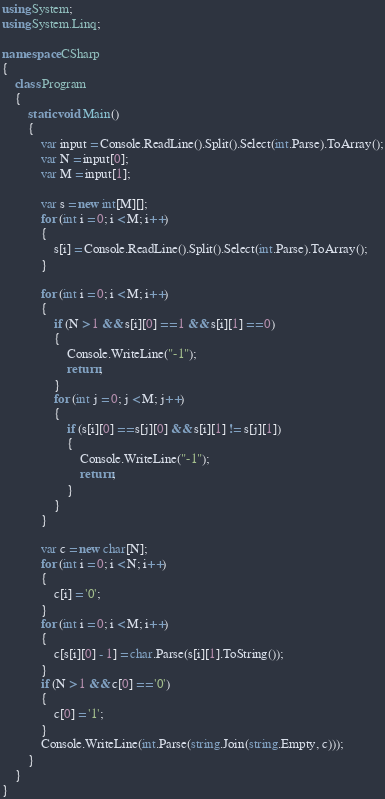<code> <loc_0><loc_0><loc_500><loc_500><_C#_>using System;
using System.Linq;

namespace CSharp
{
    class Program
    {
        static void Main()
        {
            var input = Console.ReadLine().Split().Select(int.Parse).ToArray();
            var N = input[0];
            var M = input[1];

            var s = new int[M][];
            for (int i = 0; i < M; i++)
            {
                s[i] = Console.ReadLine().Split().Select(int.Parse).ToArray();
            }

            for (int i = 0; i < M; i++)
            {
                if (N > 1 && s[i][0] == 1 && s[i][1] == 0)
                {
                    Console.WriteLine("-1");
                    return;
                }
                for (int j = 0; j < M; j++)
                {
                    if (s[i][0] == s[j][0] && s[i][1] != s[j][1])
                    {
                        Console.WriteLine("-1");
                        return;
                    }
                }
            }

            var c = new char[N];
            for (int i = 0; i < N; i++)
            {
                c[i] = '0';
            }
            for (int i = 0; i < M; i++)
            {
                c[s[i][0] - 1] = char.Parse(s[i][1].ToString());
            }
            if (N > 1 && c[0] == '0')
            {
                c[0] = '1';
            }
            Console.WriteLine(int.Parse(string.Join(string.Empty, c)));
        }
    }
}
</code> 